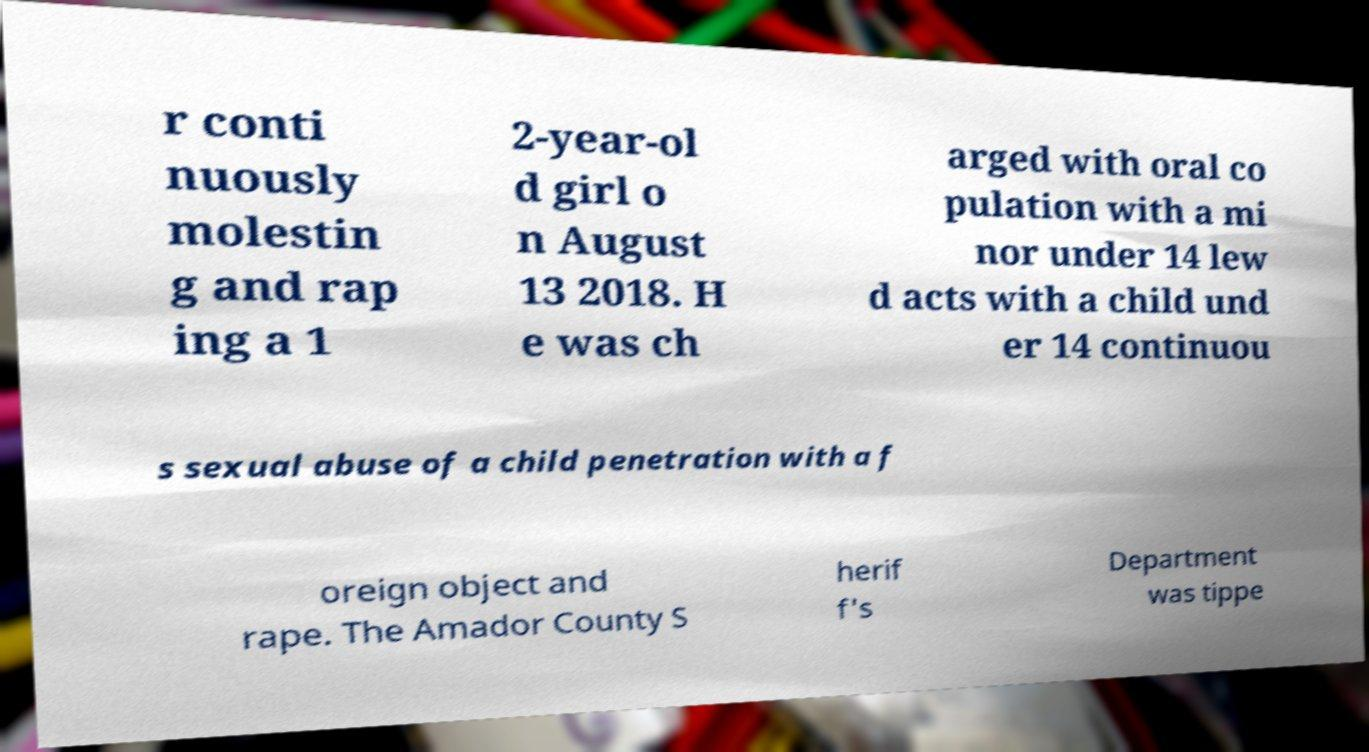I need the written content from this picture converted into text. Can you do that? r conti nuously molestin g and rap ing a 1 2-year-ol d girl o n August 13 2018. H e was ch arged with oral co pulation with a mi nor under 14 lew d acts with a child und er 14 continuou s sexual abuse of a child penetration with a f oreign object and rape. The Amador County S herif f's Department was tippe 